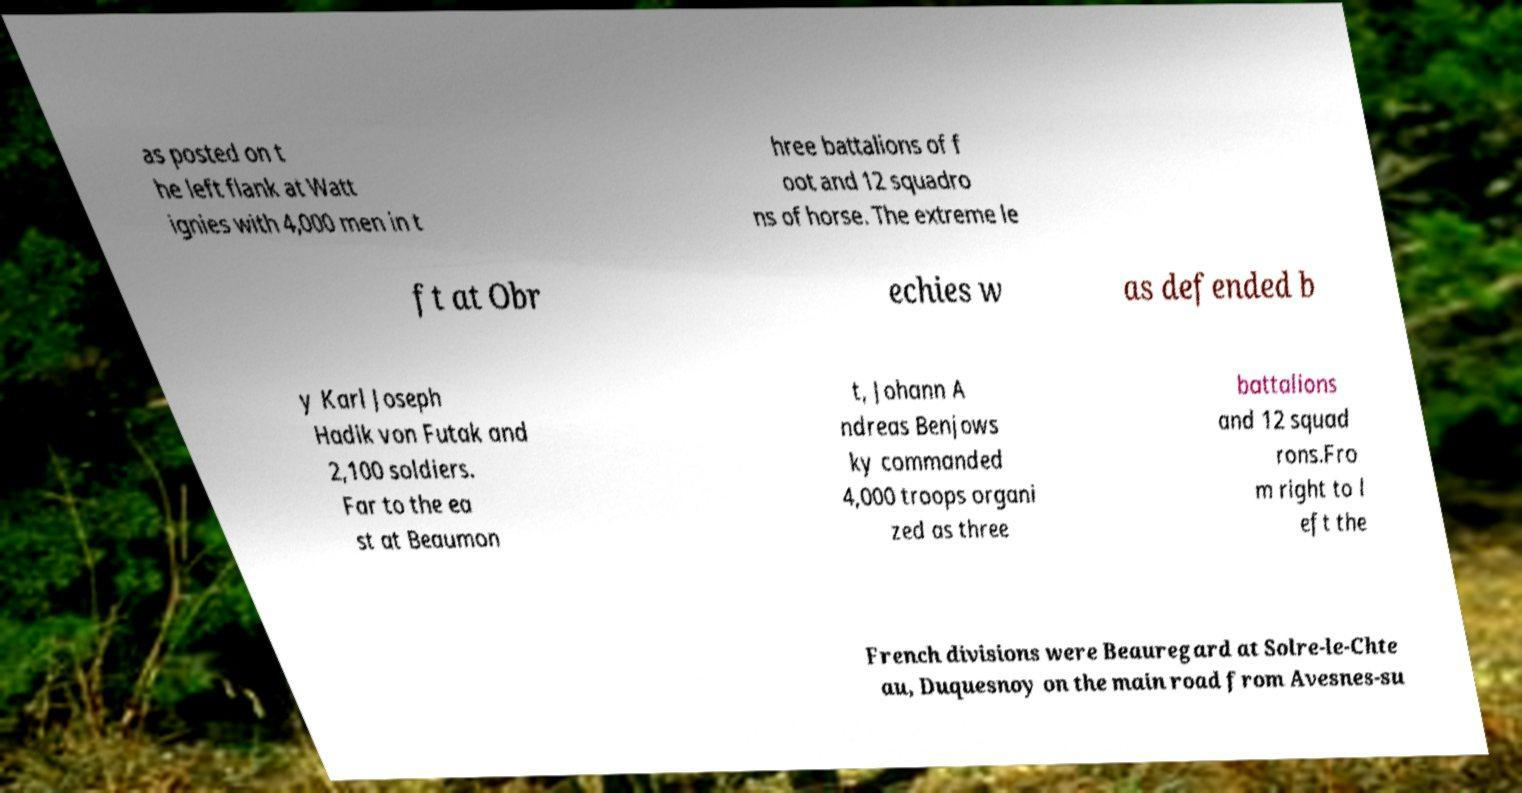Please read and relay the text visible in this image. What does it say? as posted on t he left flank at Watt ignies with 4,000 men in t hree battalions of f oot and 12 squadro ns of horse. The extreme le ft at Obr echies w as defended b y Karl Joseph Hadik von Futak and 2,100 soldiers. Far to the ea st at Beaumon t, Johann A ndreas Benjows ky commanded 4,000 troops organi zed as three battalions and 12 squad rons.Fro m right to l eft the French divisions were Beauregard at Solre-le-Chte au, Duquesnoy on the main road from Avesnes-su 